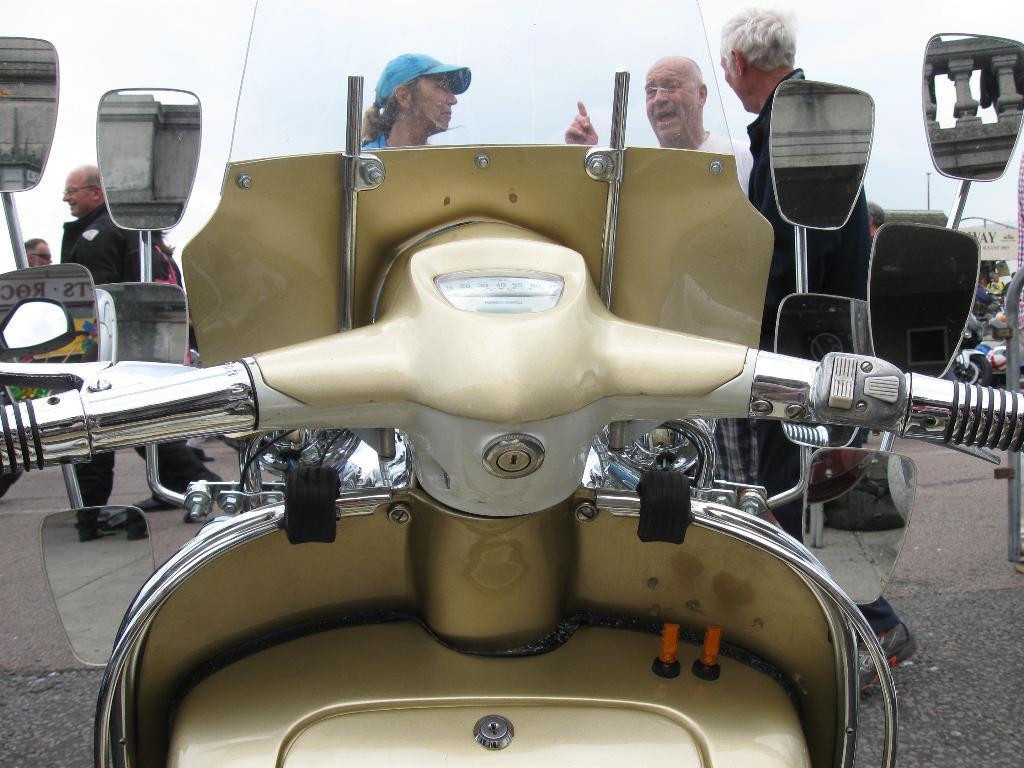In one or two sentences, can you explain what this image depicts? In this image there is a scooter handle in the middle. To the handle there are four mirrors. In front of the scooter there are three men who are discussing with each other. 